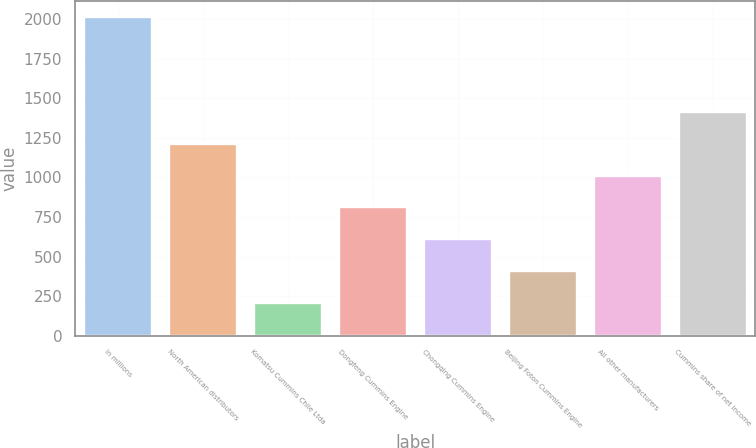<chart> <loc_0><loc_0><loc_500><loc_500><bar_chart><fcel>In millions<fcel>North American distributors<fcel>Komatsu Cummins Chile Ltda<fcel>Dongfeng Cummins Engine<fcel>Chongqing Cummins Engine<fcel>Beijing Foton Cummins Engine<fcel>All other manufacturers<fcel>Cummins share of net income<nl><fcel>2014<fcel>1211.6<fcel>208.6<fcel>810.4<fcel>609.8<fcel>409.2<fcel>1011<fcel>1412.2<nl></chart> 